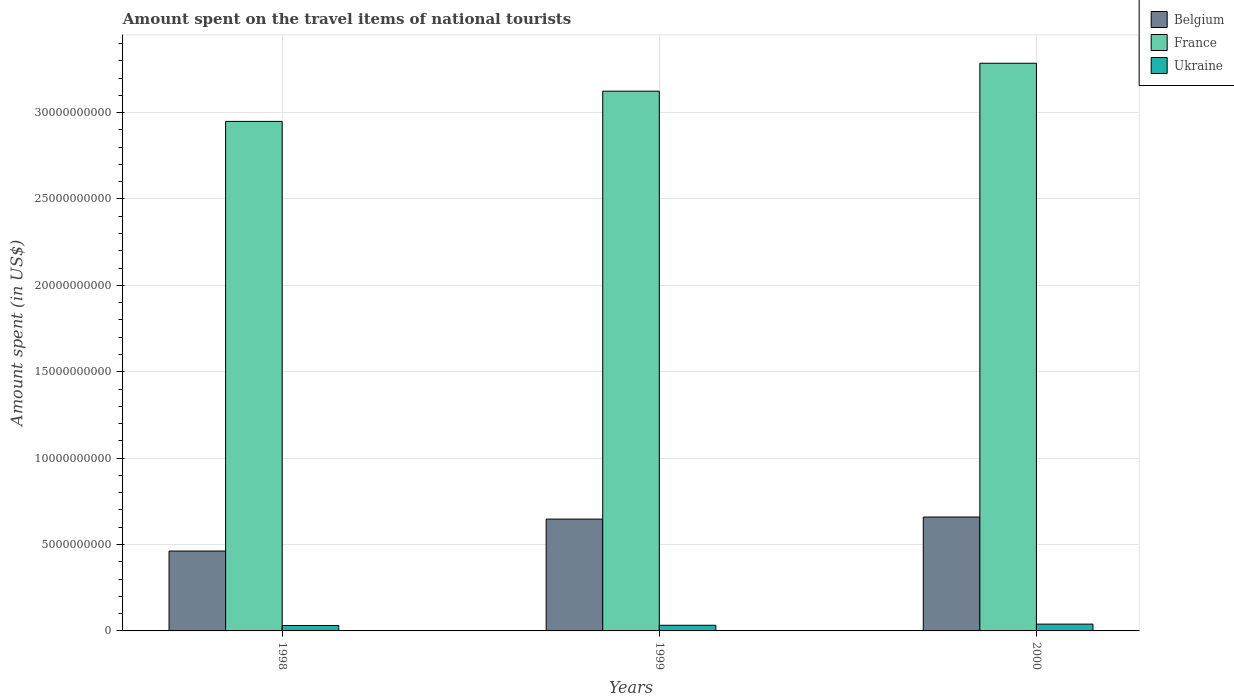Are the number of bars per tick equal to the number of legend labels?
Give a very brief answer. Yes. How many bars are there on the 3rd tick from the left?
Provide a short and direct response. 3. What is the label of the 3rd group of bars from the left?
Your answer should be compact. 2000. What is the amount spent on the travel items of national tourists in France in 1999?
Give a very brief answer. 3.12e+1. Across all years, what is the maximum amount spent on the travel items of national tourists in Belgium?
Keep it short and to the point. 6.59e+09. Across all years, what is the minimum amount spent on the travel items of national tourists in Belgium?
Offer a very short reply. 4.62e+09. In which year was the amount spent on the travel items of national tourists in France maximum?
Provide a short and direct response. 2000. What is the total amount spent on the travel items of national tourists in Belgium in the graph?
Provide a succinct answer. 1.77e+1. What is the difference between the amount spent on the travel items of national tourists in Belgium in 1998 and that in 2000?
Offer a very short reply. -1.97e+09. What is the difference between the amount spent on the travel items of national tourists in Ukraine in 2000 and the amount spent on the travel items of national tourists in France in 1998?
Your answer should be very brief. -2.91e+1. What is the average amount spent on the travel items of national tourists in Ukraine per year?
Your answer should be very brief. 3.45e+08. In the year 2000, what is the difference between the amount spent on the travel items of national tourists in France and amount spent on the travel items of national tourists in Belgium?
Offer a terse response. 2.63e+1. What is the ratio of the amount spent on the travel items of national tourists in Ukraine in 1999 to that in 2000?
Your response must be concise. 0.83. What is the difference between the highest and the second highest amount spent on the travel items of national tourists in Belgium?
Ensure brevity in your answer.  1.20e+08. What is the difference between the highest and the lowest amount spent on the travel items of national tourists in France?
Provide a succinct answer. 3.36e+09. In how many years, is the amount spent on the travel items of national tourists in Belgium greater than the average amount spent on the travel items of national tourists in Belgium taken over all years?
Ensure brevity in your answer.  2. Where does the legend appear in the graph?
Your answer should be compact. Top right. How are the legend labels stacked?
Provide a short and direct response. Vertical. What is the title of the graph?
Offer a very short reply. Amount spent on the travel items of national tourists. Does "New Caledonia" appear as one of the legend labels in the graph?
Your answer should be compact. No. What is the label or title of the Y-axis?
Keep it short and to the point. Amount spent (in US$). What is the Amount spent (in US$) in Belgium in 1998?
Provide a short and direct response. 4.62e+09. What is the Amount spent (in US$) in France in 1998?
Give a very brief answer. 2.95e+1. What is the Amount spent (in US$) in Ukraine in 1998?
Ensure brevity in your answer.  3.15e+08. What is the Amount spent (in US$) of Belgium in 1999?
Provide a succinct answer. 6.47e+09. What is the Amount spent (in US$) of France in 1999?
Provide a short and direct response. 3.12e+1. What is the Amount spent (in US$) of Ukraine in 1999?
Provide a short and direct response. 3.27e+08. What is the Amount spent (in US$) of Belgium in 2000?
Offer a very short reply. 6.59e+09. What is the Amount spent (in US$) in France in 2000?
Offer a very short reply. 3.29e+1. What is the Amount spent (in US$) of Ukraine in 2000?
Keep it short and to the point. 3.94e+08. Across all years, what is the maximum Amount spent (in US$) in Belgium?
Give a very brief answer. 6.59e+09. Across all years, what is the maximum Amount spent (in US$) of France?
Your answer should be compact. 3.29e+1. Across all years, what is the maximum Amount spent (in US$) in Ukraine?
Your answer should be compact. 3.94e+08. Across all years, what is the minimum Amount spent (in US$) in Belgium?
Give a very brief answer. 4.62e+09. Across all years, what is the minimum Amount spent (in US$) in France?
Make the answer very short. 2.95e+1. Across all years, what is the minimum Amount spent (in US$) in Ukraine?
Your response must be concise. 3.15e+08. What is the total Amount spent (in US$) in Belgium in the graph?
Your answer should be compact. 1.77e+1. What is the total Amount spent (in US$) of France in the graph?
Offer a very short reply. 9.36e+1. What is the total Amount spent (in US$) in Ukraine in the graph?
Your response must be concise. 1.04e+09. What is the difference between the Amount spent (in US$) of Belgium in 1998 and that in 1999?
Provide a short and direct response. -1.85e+09. What is the difference between the Amount spent (in US$) in France in 1998 and that in 1999?
Offer a terse response. -1.75e+09. What is the difference between the Amount spent (in US$) of Ukraine in 1998 and that in 1999?
Your answer should be very brief. -1.20e+07. What is the difference between the Amount spent (in US$) in Belgium in 1998 and that in 2000?
Offer a terse response. -1.97e+09. What is the difference between the Amount spent (in US$) in France in 1998 and that in 2000?
Provide a short and direct response. -3.36e+09. What is the difference between the Amount spent (in US$) in Ukraine in 1998 and that in 2000?
Provide a short and direct response. -7.90e+07. What is the difference between the Amount spent (in US$) in Belgium in 1999 and that in 2000?
Give a very brief answer. -1.20e+08. What is the difference between the Amount spent (in US$) of France in 1999 and that in 2000?
Your answer should be very brief. -1.62e+09. What is the difference between the Amount spent (in US$) of Ukraine in 1999 and that in 2000?
Your response must be concise. -6.70e+07. What is the difference between the Amount spent (in US$) in Belgium in 1998 and the Amount spent (in US$) in France in 1999?
Your response must be concise. -2.66e+1. What is the difference between the Amount spent (in US$) of Belgium in 1998 and the Amount spent (in US$) of Ukraine in 1999?
Your response must be concise. 4.30e+09. What is the difference between the Amount spent (in US$) in France in 1998 and the Amount spent (in US$) in Ukraine in 1999?
Provide a succinct answer. 2.92e+1. What is the difference between the Amount spent (in US$) of Belgium in 1998 and the Amount spent (in US$) of France in 2000?
Your answer should be compact. -2.82e+1. What is the difference between the Amount spent (in US$) of Belgium in 1998 and the Amount spent (in US$) of Ukraine in 2000?
Keep it short and to the point. 4.23e+09. What is the difference between the Amount spent (in US$) of France in 1998 and the Amount spent (in US$) of Ukraine in 2000?
Provide a short and direct response. 2.91e+1. What is the difference between the Amount spent (in US$) of Belgium in 1999 and the Amount spent (in US$) of France in 2000?
Ensure brevity in your answer.  -2.64e+1. What is the difference between the Amount spent (in US$) in Belgium in 1999 and the Amount spent (in US$) in Ukraine in 2000?
Provide a succinct answer. 6.08e+09. What is the difference between the Amount spent (in US$) in France in 1999 and the Amount spent (in US$) in Ukraine in 2000?
Your answer should be very brief. 3.08e+1. What is the average Amount spent (in US$) of Belgium per year?
Offer a very short reply. 5.90e+09. What is the average Amount spent (in US$) in France per year?
Your answer should be very brief. 3.12e+1. What is the average Amount spent (in US$) of Ukraine per year?
Make the answer very short. 3.45e+08. In the year 1998, what is the difference between the Amount spent (in US$) of Belgium and Amount spent (in US$) of France?
Give a very brief answer. -2.49e+1. In the year 1998, what is the difference between the Amount spent (in US$) of Belgium and Amount spent (in US$) of Ukraine?
Provide a succinct answer. 4.31e+09. In the year 1998, what is the difference between the Amount spent (in US$) in France and Amount spent (in US$) in Ukraine?
Provide a short and direct response. 2.92e+1. In the year 1999, what is the difference between the Amount spent (in US$) of Belgium and Amount spent (in US$) of France?
Provide a succinct answer. -2.48e+1. In the year 1999, what is the difference between the Amount spent (in US$) in Belgium and Amount spent (in US$) in Ukraine?
Your answer should be compact. 6.14e+09. In the year 1999, what is the difference between the Amount spent (in US$) in France and Amount spent (in US$) in Ukraine?
Offer a terse response. 3.09e+1. In the year 2000, what is the difference between the Amount spent (in US$) in Belgium and Amount spent (in US$) in France?
Offer a terse response. -2.63e+1. In the year 2000, what is the difference between the Amount spent (in US$) in Belgium and Amount spent (in US$) in Ukraine?
Provide a succinct answer. 6.20e+09. In the year 2000, what is the difference between the Amount spent (in US$) in France and Amount spent (in US$) in Ukraine?
Provide a short and direct response. 3.25e+1. What is the ratio of the Amount spent (in US$) in France in 1998 to that in 1999?
Your answer should be very brief. 0.94. What is the ratio of the Amount spent (in US$) of Ukraine in 1998 to that in 1999?
Your answer should be very brief. 0.96. What is the ratio of the Amount spent (in US$) of Belgium in 1998 to that in 2000?
Offer a very short reply. 0.7. What is the ratio of the Amount spent (in US$) of France in 1998 to that in 2000?
Offer a terse response. 0.9. What is the ratio of the Amount spent (in US$) in Ukraine in 1998 to that in 2000?
Your response must be concise. 0.8. What is the ratio of the Amount spent (in US$) of Belgium in 1999 to that in 2000?
Make the answer very short. 0.98. What is the ratio of the Amount spent (in US$) in France in 1999 to that in 2000?
Give a very brief answer. 0.95. What is the ratio of the Amount spent (in US$) in Ukraine in 1999 to that in 2000?
Provide a succinct answer. 0.83. What is the difference between the highest and the second highest Amount spent (in US$) of Belgium?
Provide a succinct answer. 1.20e+08. What is the difference between the highest and the second highest Amount spent (in US$) in France?
Your answer should be very brief. 1.62e+09. What is the difference between the highest and the second highest Amount spent (in US$) of Ukraine?
Offer a terse response. 6.70e+07. What is the difference between the highest and the lowest Amount spent (in US$) of Belgium?
Keep it short and to the point. 1.97e+09. What is the difference between the highest and the lowest Amount spent (in US$) in France?
Keep it short and to the point. 3.36e+09. What is the difference between the highest and the lowest Amount spent (in US$) of Ukraine?
Your answer should be very brief. 7.90e+07. 